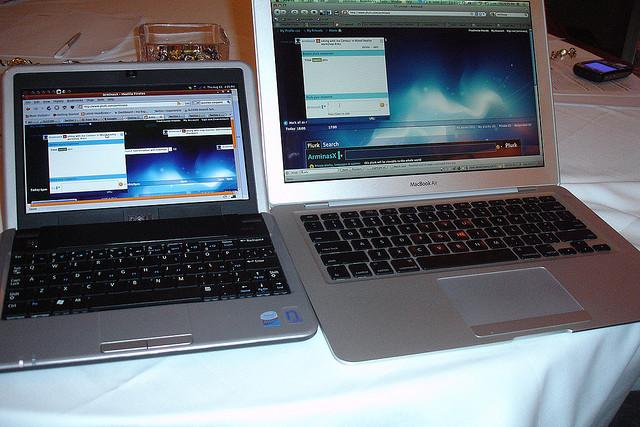What is side by side?

Choices:
A) babies
B) rabbits
C) laptops
D) cows laptops 